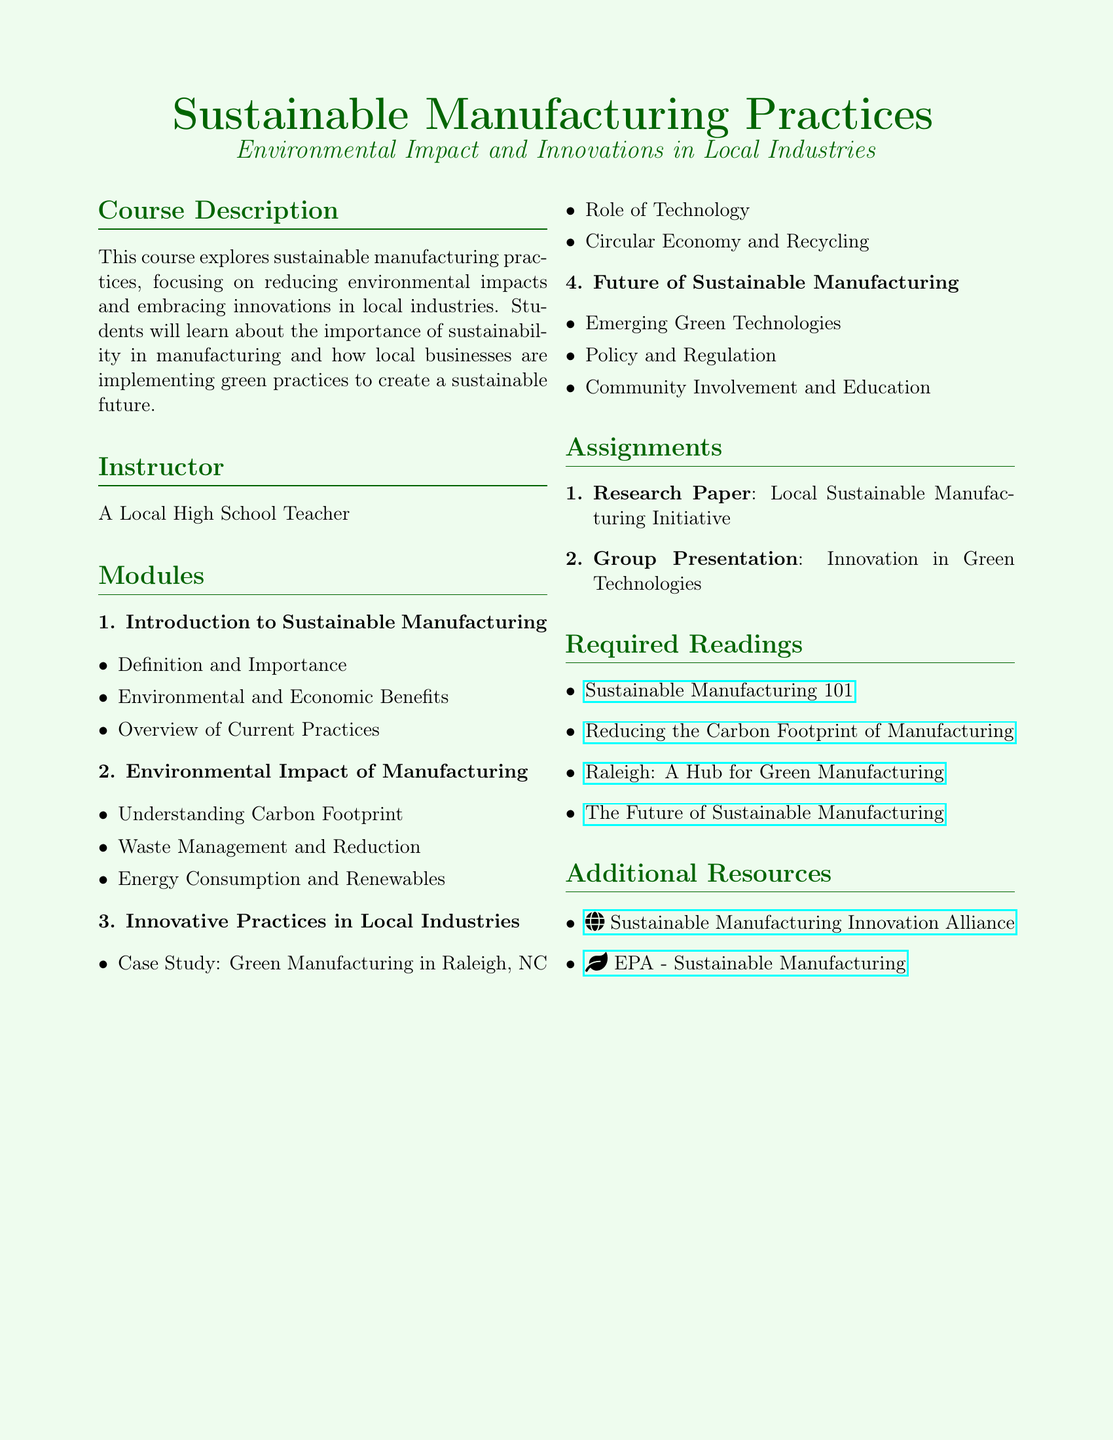What is the main focus of the course? The course primarily focuses on sustainable manufacturing practices, particularly how they reduce environmental impacts and embrace innovations in local industries.
Answer: Sustainable manufacturing practices Who is the instructor for the course? The syllabus lists the instructor as "A Local High School Teacher."
Answer: A Local High School Teacher What is one of the required readings? The syllabus includes several required readings, one of which is titled "Reducing the Carbon Footprint of Manufacturing."
Answer: Reducing the Carbon Footprint of Manufacturing How many modules are in the syllabus? The syllabus outlines a total of four modules that cover different aspects of sustainable manufacturing.
Answer: Four What type of assignment requires a group effort? The syllabus includes an assignment type which involves a group presentation on innovation in green technologies.
Answer: Group Presentation What is one case study mentioned in the course? The syllabus specifically mentions a case study about green manufacturing in Raleigh, NC.
Answer: Green manufacturing in Raleigh, NC What is the last module titled? The last module discusses the future of sustainable manufacturing and its various components.
Answer: Future of Sustainable Manufacturing What is the purpose of the course assignments? The course assignments are designed to deepen understanding of local sustainable manufacturing initiatives and innovations in green technologies.
Answer: To deepen understanding 